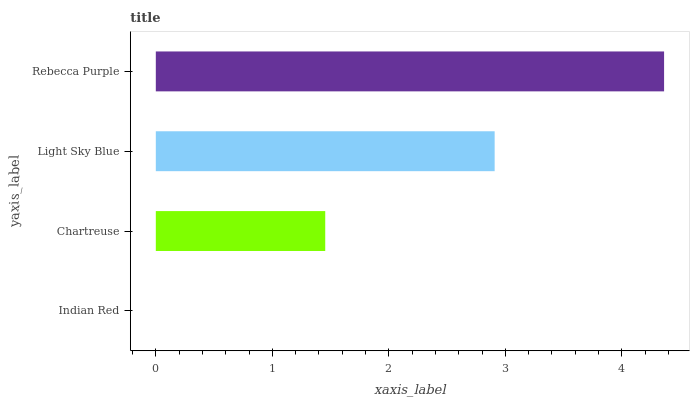Is Indian Red the minimum?
Answer yes or no. Yes. Is Rebecca Purple the maximum?
Answer yes or no. Yes. Is Chartreuse the minimum?
Answer yes or no. No. Is Chartreuse the maximum?
Answer yes or no. No. Is Chartreuse greater than Indian Red?
Answer yes or no. Yes. Is Indian Red less than Chartreuse?
Answer yes or no. Yes. Is Indian Red greater than Chartreuse?
Answer yes or no. No. Is Chartreuse less than Indian Red?
Answer yes or no. No. Is Light Sky Blue the high median?
Answer yes or no. Yes. Is Chartreuse the low median?
Answer yes or no. Yes. Is Rebecca Purple the high median?
Answer yes or no. No. Is Light Sky Blue the low median?
Answer yes or no. No. 